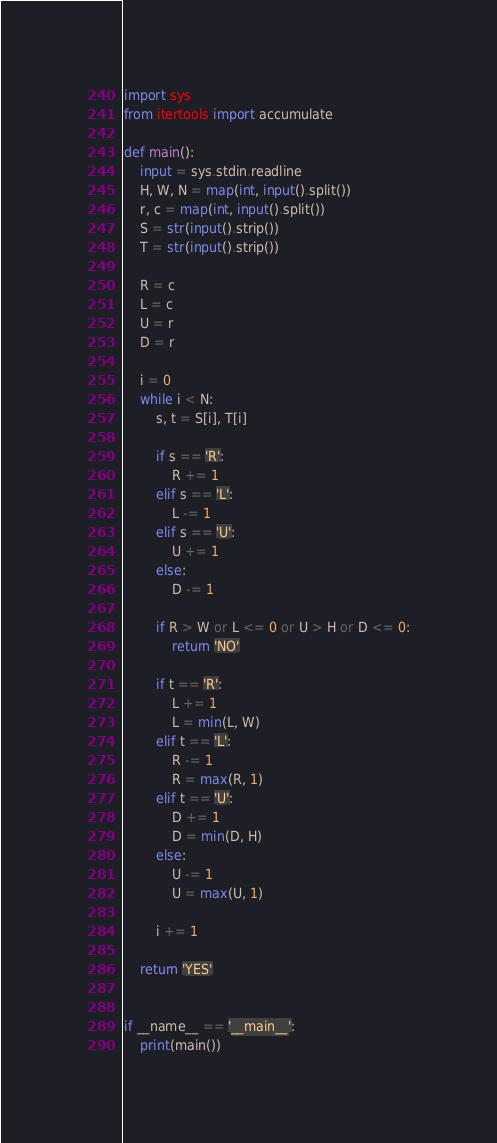Convert code to text. <code><loc_0><loc_0><loc_500><loc_500><_Python_>import sys
from itertools import accumulate

def main():
    input = sys.stdin.readline
    H, W, N = map(int, input().split())
    r, c = map(int, input().split())
    S = str(input().strip())
    T = str(input().strip())

    R = c
    L = c
    U = r
    D = r

    i = 0
    while i < N:
        s, t = S[i], T[i]

        if s == 'R':
            R += 1
        elif s == 'L':
            L -= 1
        elif s == 'U':
            U += 1
        else:
            D -= 1

        if R > W or L <= 0 or U > H or D <= 0:
            return 'NO'

        if t == 'R':
            L += 1
            L = min(L, W)
        elif t == 'L':
            R -= 1
            R = max(R, 1)
        elif t == 'U':
            D += 1
            D = min(D, H)
        else:
            U -= 1
            U = max(U, 1)

        i += 1

    return 'YES' 


if __name__ == '__main__':
    print(main())
</code> 